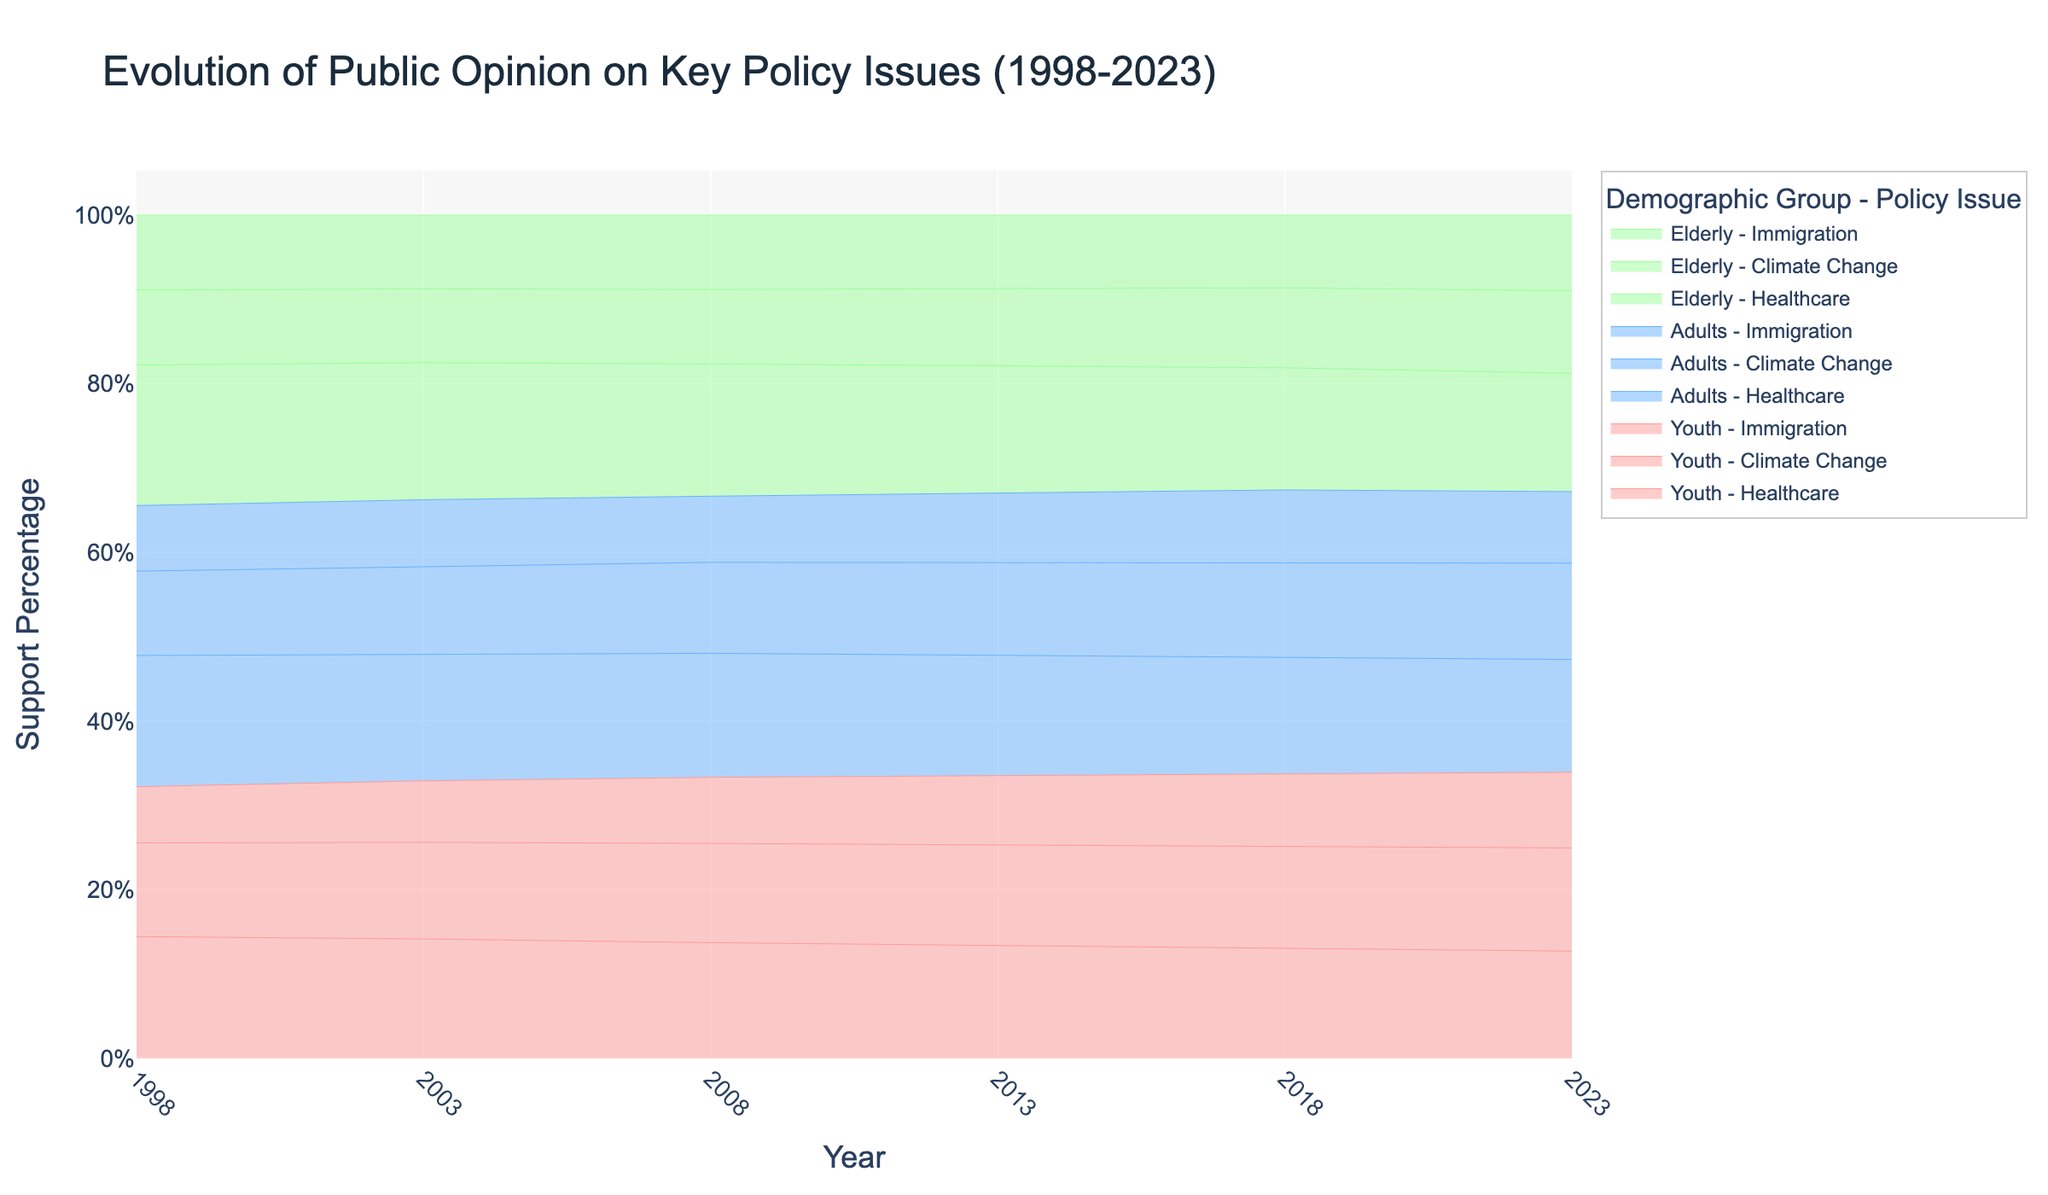What is the title of the area chart? The title of the chart is displayed at the top center of the plot, indicating the main subject of the visual.
Answer: Evolution of Public Opinion on Key Policy Issues (1998-2023) What does the y-axis represent in the chart? The y-axis represents the percentage of support for the key policy issues among different demographic groups over time.
Answer: Support Percentage How has the support for healthcare changed for the elderly from 1998 to 2023? To find this, we locate the line representing elderly support for healthcare in the chart and observe the change from 1998 to 2023. Elderly support for healthcare increased from 75% in 1998 to 86% in 2023.
Answer: Increased from 75% to 86% Which demographic group showed the highest support for climate change action in 2023? By examining the different lines representing each group's support for climate change in 2023, we see that the youth had the highest support at 75%.
Answer: Youth What is the trend in support for immigration among adults from 1998 to 2023? By observing the line representing adult support for immigration, we see it increased from 35% in 1998 to 52% in 2023.
Answer: Increased from 35% to 52% Compare the support for climate change between youth and elderly in 2018. In the area chart, we compare the lines for youth and elderly under climate change in 2018. Youth support was at 70%, while elderly support was at 55%.
Answer: Youth: 70%, Elderly: 55% What was the support percentage for immigration among youth in 2008? Locate the specific value on the area chart where youth support for immigration is indicated in 2008. The support was 40%.
Answer: 40% Identify the policy issue with the most significant increase in support among adults between 1998 and 2023. By observing the trends in support for each policy issue among adults, healthcare saw the most substantial increase from 70% in 1998 to 82% in 2023.
Answer: Healthcare How did the support for climate change among all demographic groups evolve from 2003 to 2018? Reviewing the lines for climate change support for each group from 2003 to 2018, we observe an increasing trend: Youth from 55% to 70%, Adults from 50% to 65%, and Elderly from 42% to 55%.
Answer: Increased for all groups Which demographic group showed the smallest change in support for immigration from 1998 to 2023? By comparing the immigration support lines for all groups, the smallest change occurred among adults, who increased from 35% to 52%, a smaller range compared to others.
Answer: Adults 